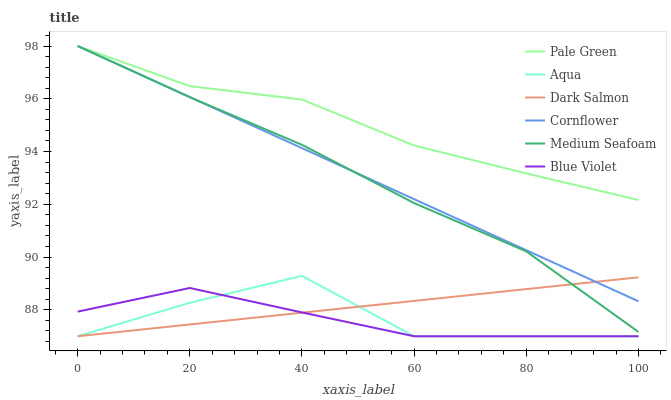Does Blue Violet have the minimum area under the curve?
Answer yes or no. Yes. Does Pale Green have the maximum area under the curve?
Answer yes or no. Yes. Does Aqua have the minimum area under the curve?
Answer yes or no. No. Does Aqua have the maximum area under the curve?
Answer yes or no. No. Is Cornflower the smoothest?
Answer yes or no. Yes. Is Aqua the roughest?
Answer yes or no. Yes. Is Dark Salmon the smoothest?
Answer yes or no. No. Is Dark Salmon the roughest?
Answer yes or no. No. Does Aqua have the lowest value?
Answer yes or no. Yes. Does Pale Green have the lowest value?
Answer yes or no. No. Does Medium Seafoam have the highest value?
Answer yes or no. Yes. Does Aqua have the highest value?
Answer yes or no. No. Is Aqua less than Pale Green?
Answer yes or no. Yes. Is Pale Green greater than Blue Violet?
Answer yes or no. Yes. Does Medium Seafoam intersect Dark Salmon?
Answer yes or no. Yes. Is Medium Seafoam less than Dark Salmon?
Answer yes or no. No. Is Medium Seafoam greater than Dark Salmon?
Answer yes or no. No. Does Aqua intersect Pale Green?
Answer yes or no. No. 